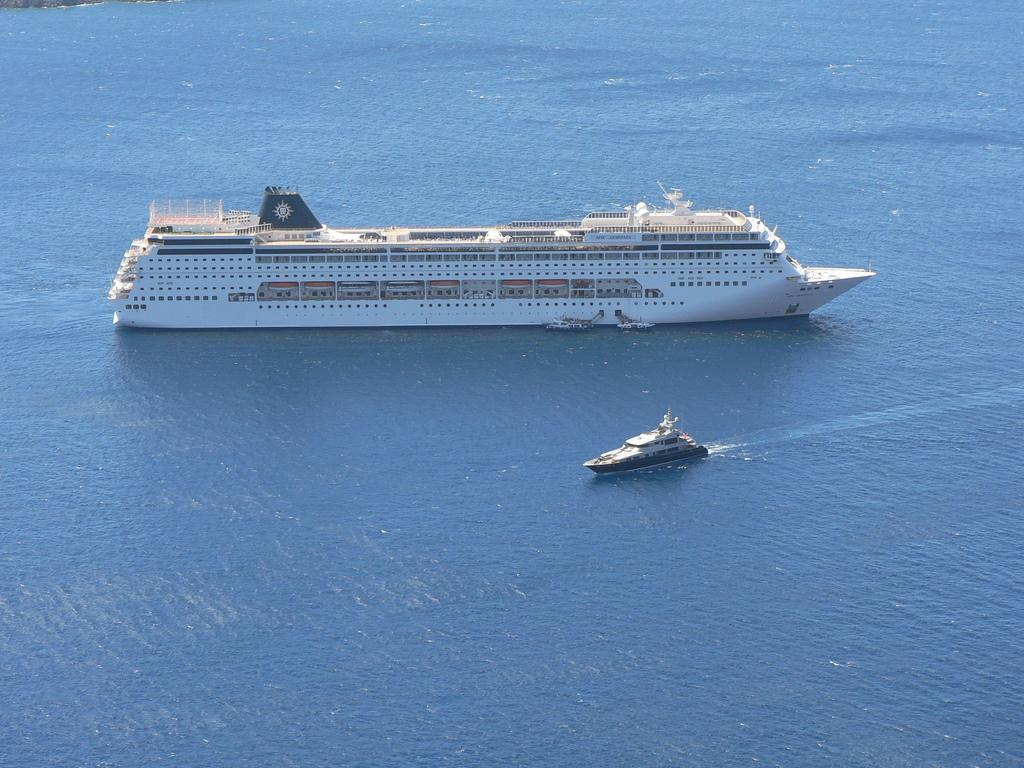Where was the image taken? The image was clicked outside the city. What can be seen in the water body in the image? There are boats and a ship in the water body. What type of bag is the farmer carrying on his journey in the image? There is no farmer or bag present in the image. What type of journey is the ship taking in the image? The image does not provide information about the ship's journey; it only shows the ship in the water body. 